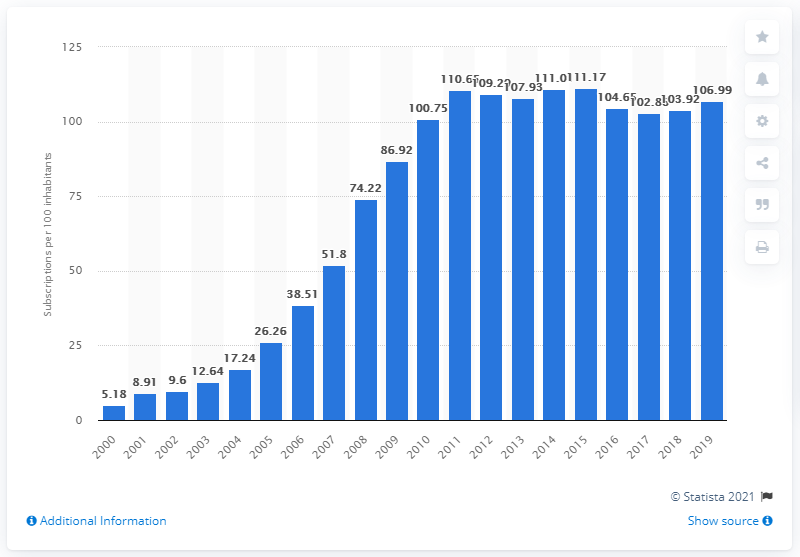Identify some key points in this picture. In 2000, the number of mobile cellular subscriptions per 100 inhabitants in Azerbaijan was. Between 2000 and 2019, there were an average of 106.99 mobile subscriptions registered for every 100 people in Azerbaijan. 